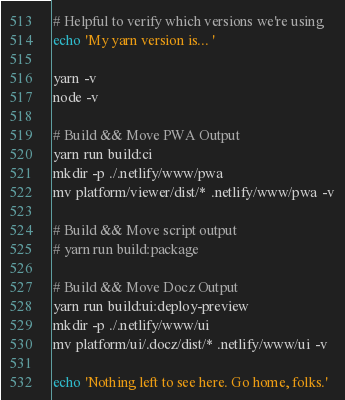Convert code to text. <code><loc_0><loc_0><loc_500><loc_500><_Bash_>
# Helpful to verify which versions we're using
echo 'My yarn version is... '

yarn -v
node -v

# Build && Move PWA Output
yarn run build:ci
mkdir -p ./.netlify/www/pwa
mv platform/viewer/dist/* .netlify/www/pwa -v

# Build && Move script output
# yarn run build:package

# Build && Move Docz Output
yarn run build:ui:deploy-preview
mkdir -p ./.netlify/www/ui
mv platform/ui/.docz/dist/* .netlify/www/ui -v

echo 'Nothing left to see here. Go home, folks.'
</code> 